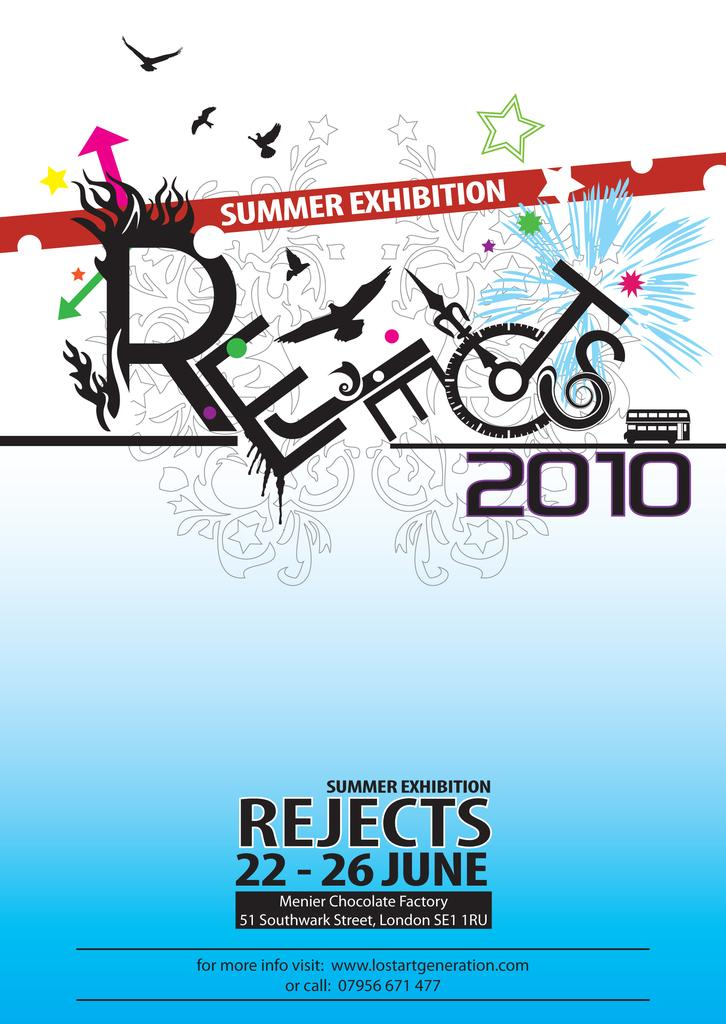<image>
Render a clear and concise summary of the photo. An advertisement for a summer exhibition called Rejects 2010 will run from June 22-26. 